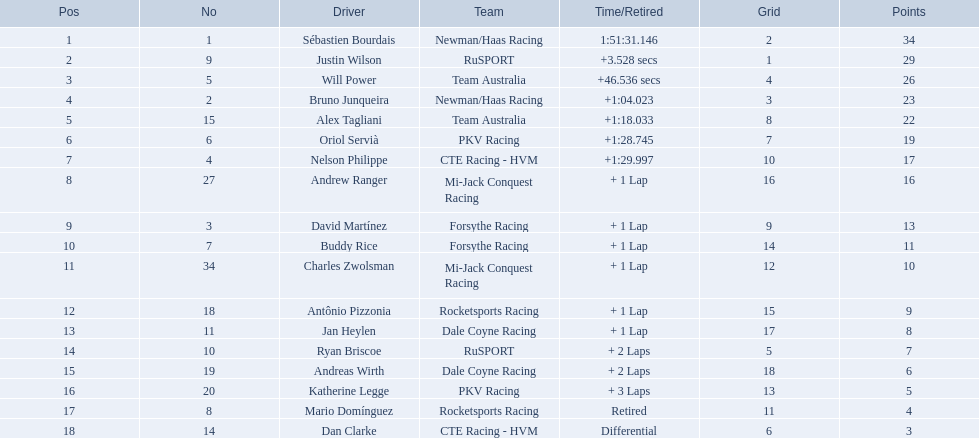Write the full table. {'header': ['Pos', 'No', 'Driver', 'Team', 'Time/Retired', 'Grid', 'Points'], 'rows': [['1', '1', 'Sébastien Bourdais', 'Newman/Haas Racing', '1:51:31.146', '2', '34'], ['2', '9', 'Justin Wilson', 'RuSPORT', '+3.528 secs', '1', '29'], ['3', '5', 'Will Power', 'Team Australia', '+46.536 secs', '4', '26'], ['4', '2', 'Bruno Junqueira', 'Newman/Haas Racing', '+1:04.023', '3', '23'], ['5', '15', 'Alex Tagliani', 'Team Australia', '+1:18.033', '8', '22'], ['6', '6', 'Oriol Servià', 'PKV Racing', '+1:28.745', '7', '19'], ['7', '4', 'Nelson Philippe', 'CTE Racing - HVM', '+1:29.997', '10', '17'], ['8', '27', 'Andrew Ranger', 'Mi-Jack Conquest Racing', '+ 1 Lap', '16', '16'], ['9', '3', 'David Martínez', 'Forsythe Racing', '+ 1 Lap', '9', '13'], ['10', '7', 'Buddy Rice', 'Forsythe Racing', '+ 1 Lap', '14', '11'], ['11', '34', 'Charles Zwolsman', 'Mi-Jack Conquest Racing', '+ 1 Lap', '12', '10'], ['12', '18', 'Antônio Pizzonia', 'Rocketsports Racing', '+ 1 Lap', '15', '9'], ['13', '11', 'Jan Heylen', 'Dale Coyne Racing', '+ 1 Lap', '17', '8'], ['14', '10', 'Ryan Briscoe', 'RuSPORT', '+ 2 Laps', '5', '7'], ['15', '19', 'Andreas Wirth', 'Dale Coyne Racing', '+ 2 Laps', '18', '6'], ['16', '20', 'Katherine Legge', 'PKV Racing', '+ 3 Laps', '13', '5'], ['17', '8', 'Mario Domínguez', 'Rocketsports Racing', 'Retired', '11', '4'], ['18', '14', 'Dan Clarke', 'CTE Racing - HVM', 'Differential', '6', '3']]} What are the drivers numbers? 1, 9, 5, 2, 15, 6, 4, 27, 3, 7, 34, 18, 11, 10, 19, 20, 8, 14. Are there any who's number matches his position? Sébastien Bourdais, Oriol Servià. Of those two who has the highest position? Sébastien Bourdais. 